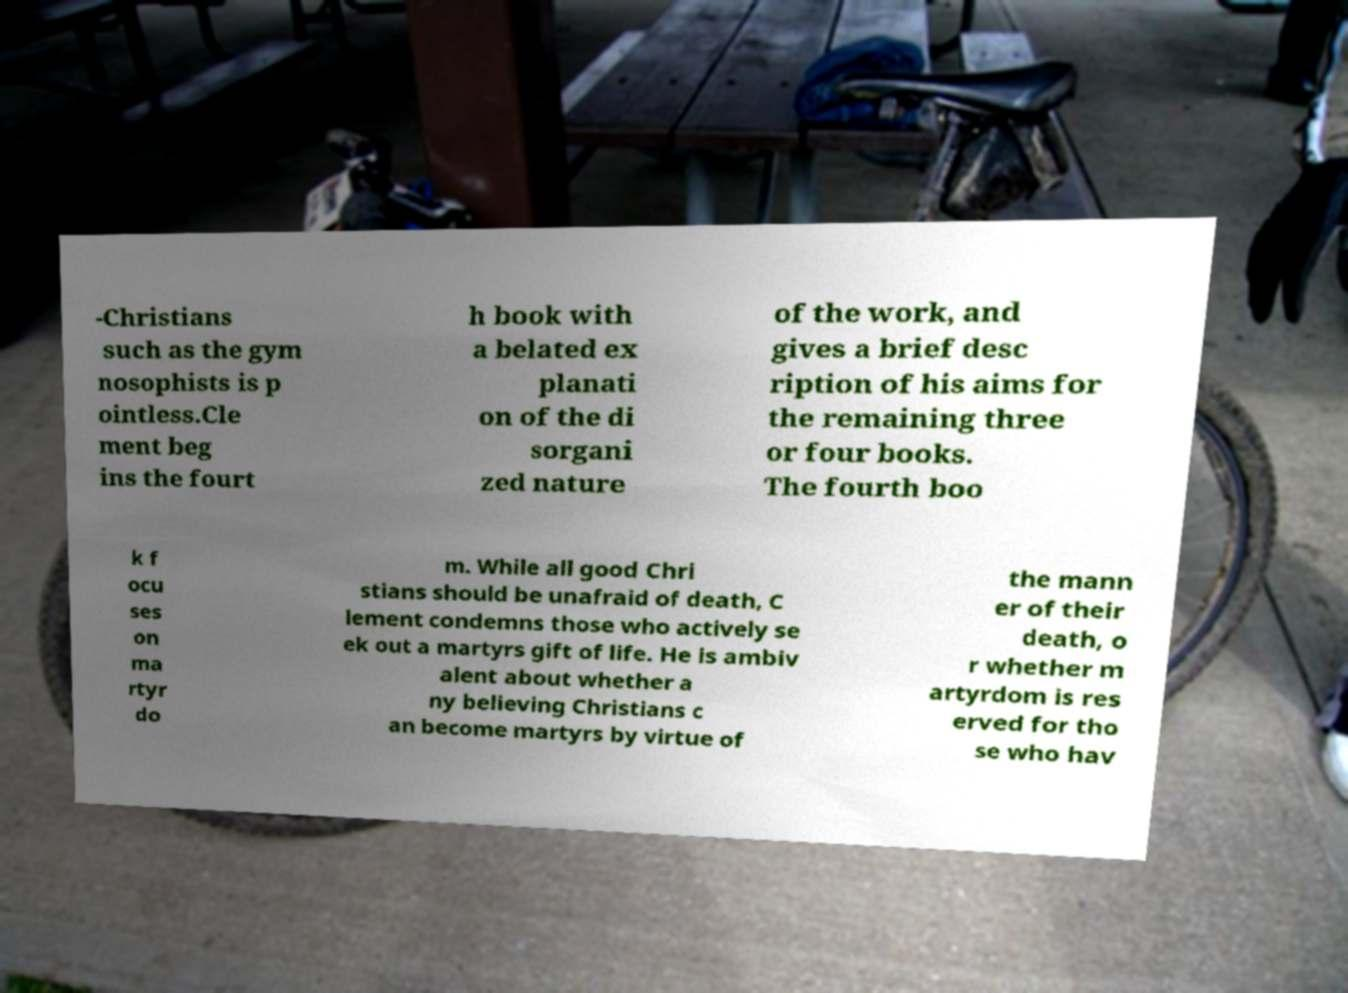What messages or text are displayed in this image? I need them in a readable, typed format. -Christians such as the gym nosophists is p ointless.Cle ment beg ins the fourt h book with a belated ex planati on of the di sorgani zed nature of the work, and gives a brief desc ription of his aims for the remaining three or four books. The fourth boo k f ocu ses on ma rtyr do m. While all good Chri stians should be unafraid of death, C lement condemns those who actively se ek out a martyrs gift of life. He is ambiv alent about whether a ny believing Christians c an become martyrs by virtue of the mann er of their death, o r whether m artyrdom is res erved for tho se who hav 